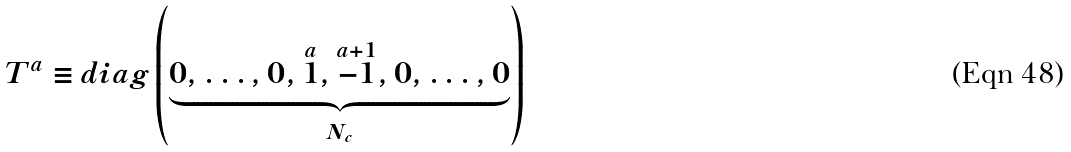Convert formula to latex. <formula><loc_0><loc_0><loc_500><loc_500>T ^ { a } \equiv d i a g \left ( \underbrace { 0 , \dots , 0 , \overset { a } { 1 } , \overset { a + 1 } { - 1 } , 0 , \dots , 0 } _ { N _ { c } } \right )</formula> 